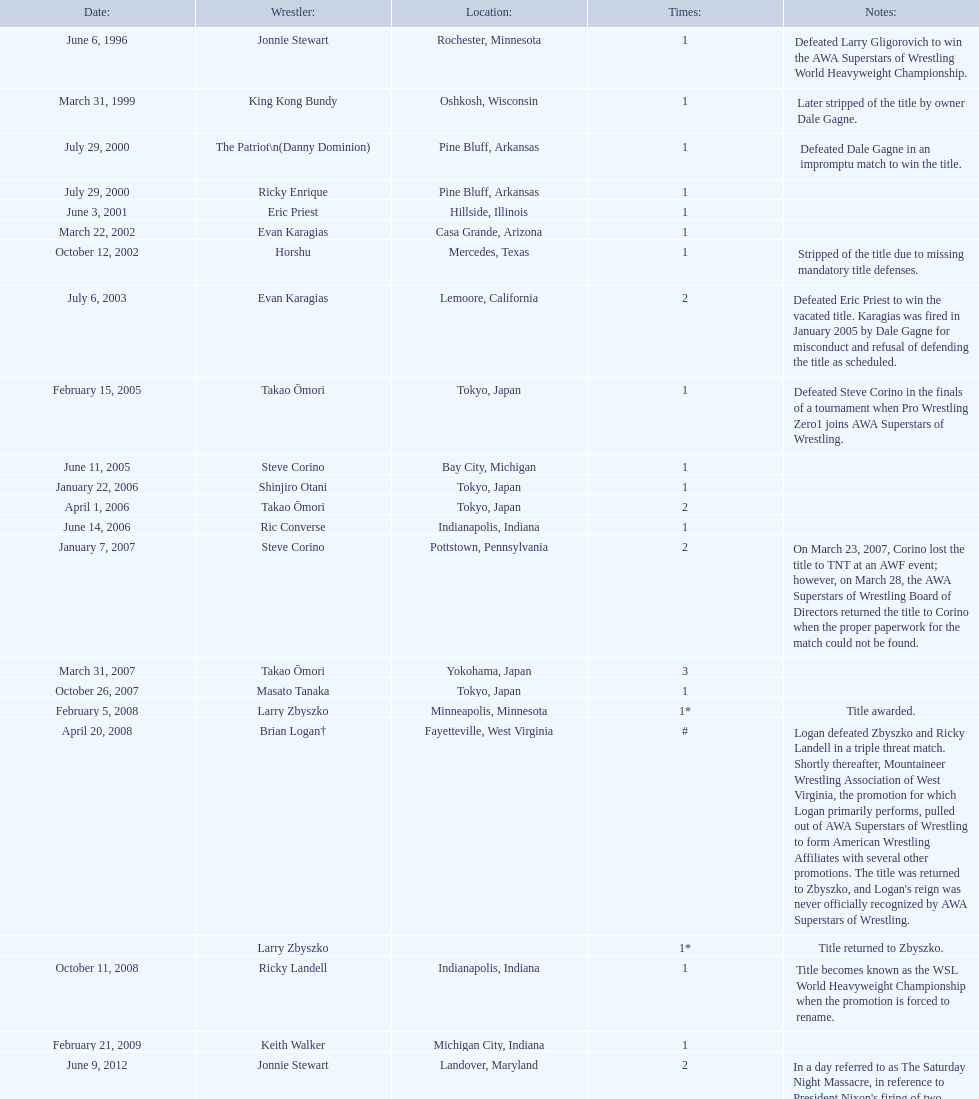Who is the only wsl title holder from texas? Horshu. 